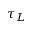<formula> <loc_0><loc_0><loc_500><loc_500>\tau _ { L }</formula> 